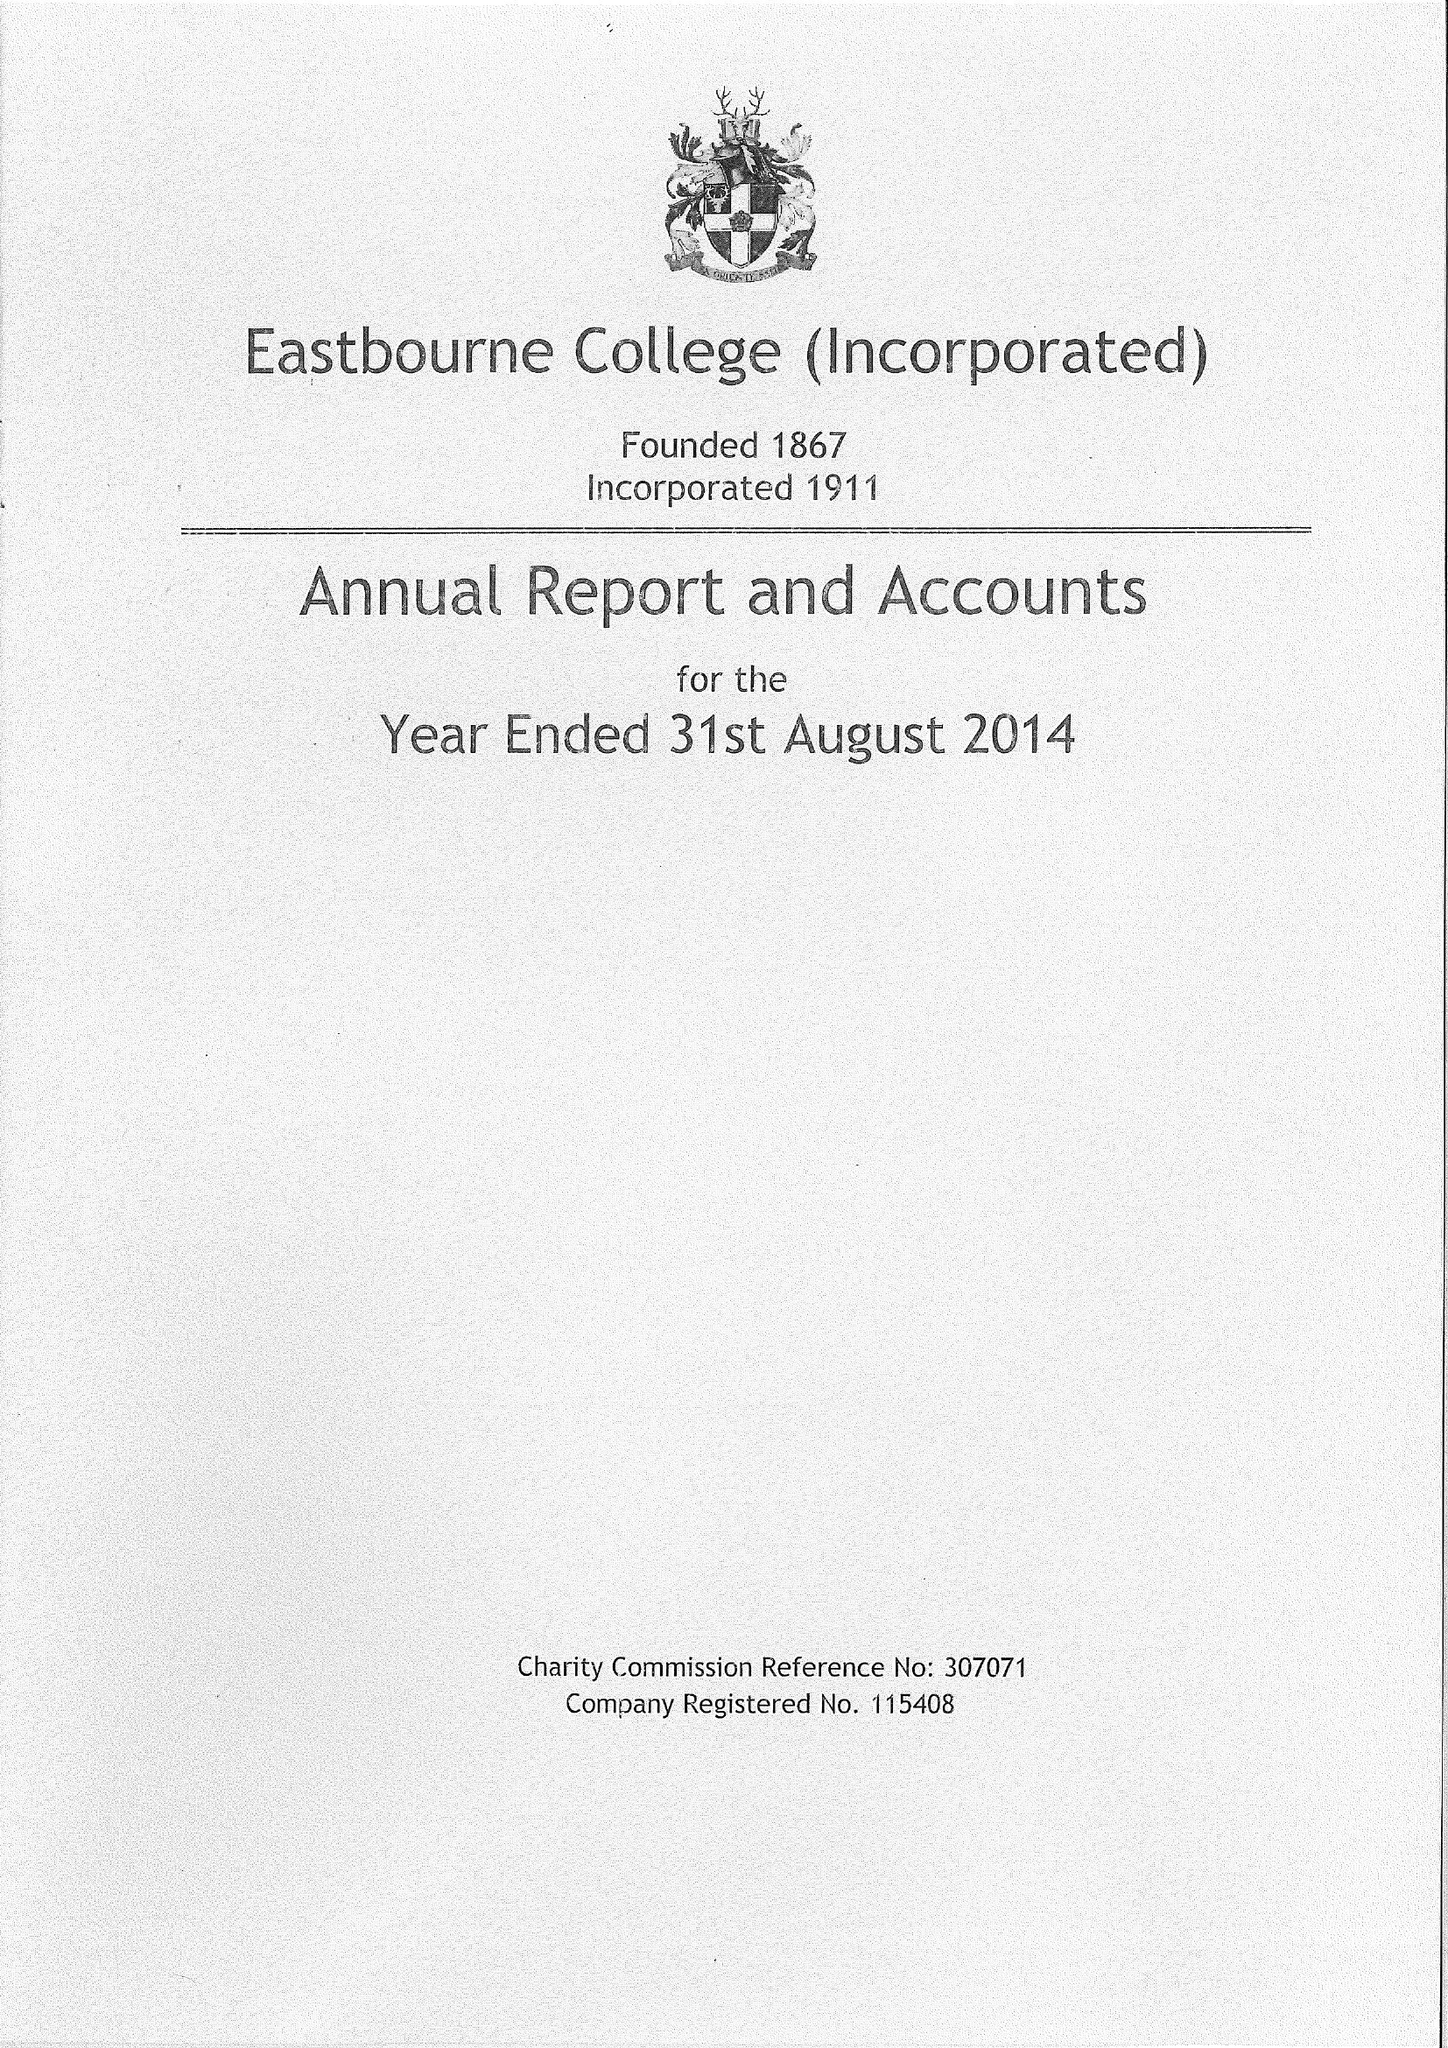What is the value for the charity_name?
Answer the question using a single word or phrase. Eastbourne College (Incorporated) 